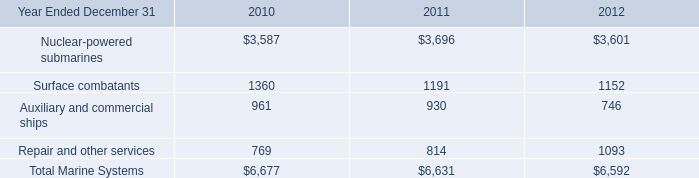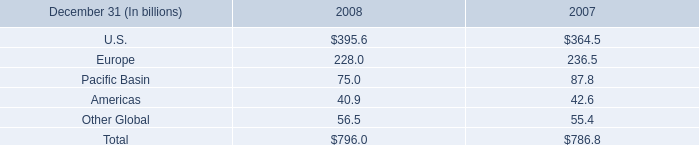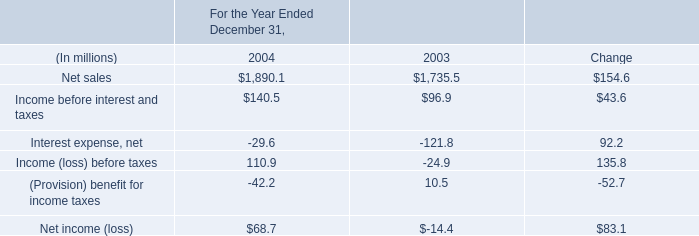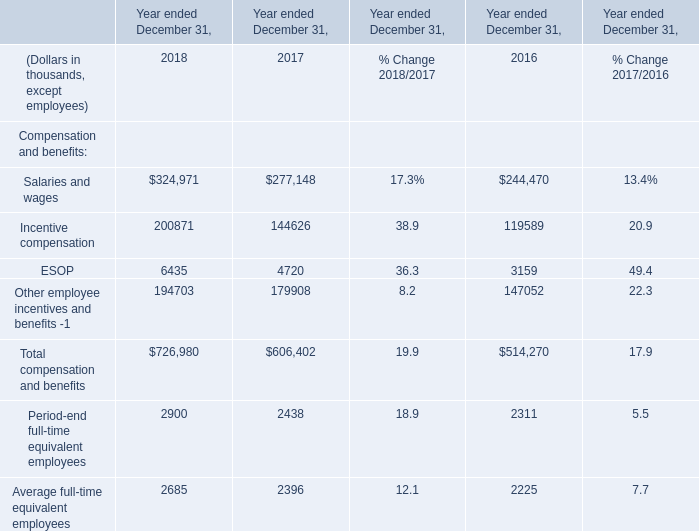If Total compensation and benefits develops with the same growth rate as in 2017 ended December 31, what will it reach in 2018 ended December 31? (in thousand) 
Computations: (606402 * (1 + ((606402 - 514270) / 514270)))
Answer: 715039.54266. 